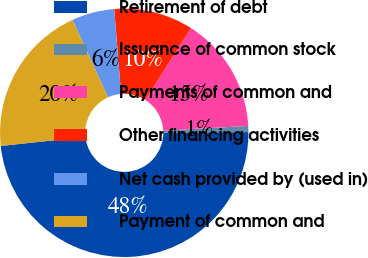Convert chart. <chart><loc_0><loc_0><loc_500><loc_500><pie_chart><fcel>Retirement of debt<fcel>Issuance of common stock<fcel>Payments of common and<fcel>Other financing activities<fcel>Net cash provided by (used in)<fcel>Payment of common and<nl><fcel>48.41%<fcel>0.79%<fcel>15.08%<fcel>10.32%<fcel>5.56%<fcel>19.84%<nl></chart> 